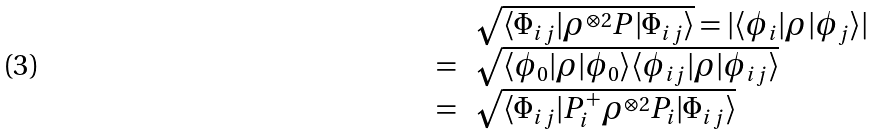Convert formula to latex. <formula><loc_0><loc_0><loc_500><loc_500>\begin{array} { r l } & \sqrt { \langle \Phi _ { i j } | \rho ^ { \otimes 2 } P | \Phi _ { i j } \rangle } = | \langle \phi _ { i } | \rho | \phi _ { j } \rangle | \\ = & \sqrt { \langle \phi _ { 0 } | \rho | \phi _ { 0 } \rangle \langle \phi _ { i j } | \rho | \phi _ { i j } \rangle } \\ = & \sqrt { \langle \Phi _ { i j } | P _ { i } ^ { + } \rho ^ { \otimes 2 } P _ { i } | \Phi _ { i j } \rangle } \end{array}</formula> 